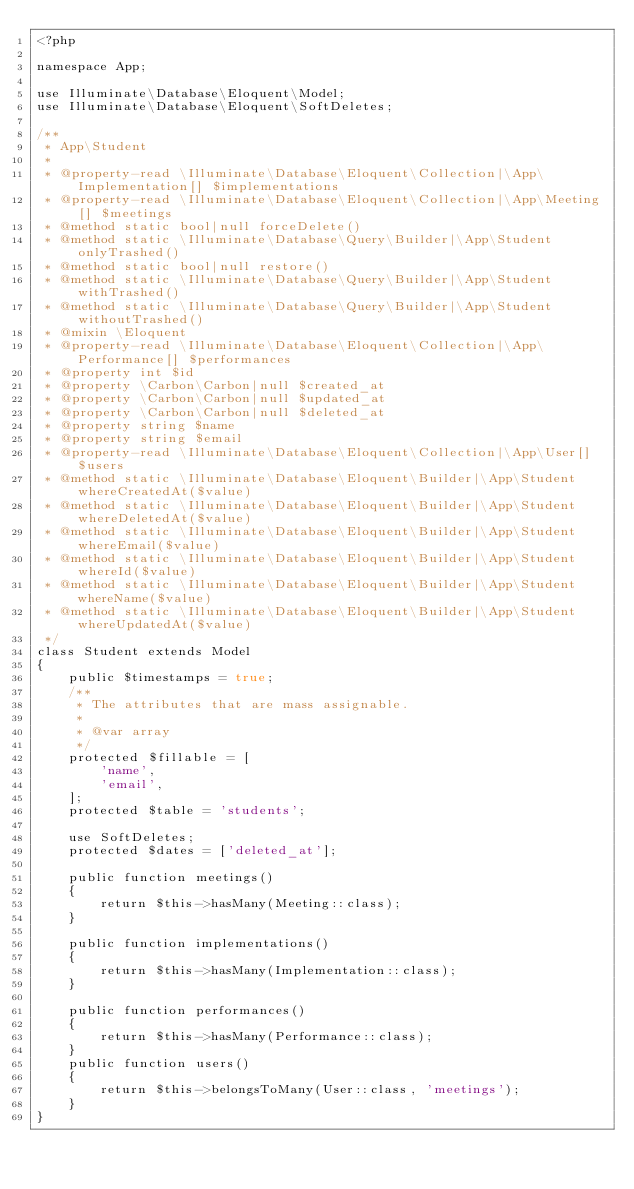Convert code to text. <code><loc_0><loc_0><loc_500><loc_500><_PHP_><?php

namespace App;

use Illuminate\Database\Eloquent\Model;
use Illuminate\Database\Eloquent\SoftDeletes;

/**
 * App\Student
 *
 * @property-read \Illuminate\Database\Eloquent\Collection|\App\Implementation[] $implementations
 * @property-read \Illuminate\Database\Eloquent\Collection|\App\Meeting[] $meetings
 * @method static bool|null forceDelete()
 * @method static \Illuminate\Database\Query\Builder|\App\Student onlyTrashed()
 * @method static bool|null restore()
 * @method static \Illuminate\Database\Query\Builder|\App\Student withTrashed()
 * @method static \Illuminate\Database\Query\Builder|\App\Student withoutTrashed()
 * @mixin \Eloquent
 * @property-read \Illuminate\Database\Eloquent\Collection|\App\Performance[] $performances
 * @property int $id
 * @property \Carbon\Carbon|null $created_at
 * @property \Carbon\Carbon|null $updated_at
 * @property \Carbon\Carbon|null $deleted_at
 * @property string $name
 * @property string $email
 * @property-read \Illuminate\Database\Eloquent\Collection|\App\User[] $users
 * @method static \Illuminate\Database\Eloquent\Builder|\App\Student whereCreatedAt($value)
 * @method static \Illuminate\Database\Eloquent\Builder|\App\Student whereDeletedAt($value)
 * @method static \Illuminate\Database\Eloquent\Builder|\App\Student whereEmail($value)
 * @method static \Illuminate\Database\Eloquent\Builder|\App\Student whereId($value)
 * @method static \Illuminate\Database\Eloquent\Builder|\App\Student whereName($value)
 * @method static \Illuminate\Database\Eloquent\Builder|\App\Student whereUpdatedAt($value)
 */
class Student extends Model
{
    public $timestamps = true;
    /**
     * The attributes that are mass assignable.
     *
     * @var array
     */
    protected $fillable = [
        'name',
        'email',
    ];
    protected $table = 'students';

    use SoftDeletes;
    protected $dates = ['deleted_at'];

    public function meetings()
    {
        return $this->hasMany(Meeting::class);
    }

    public function implementations()
    {
        return $this->hasMany(Implementation::class);
    }

    public function performances()
    {
        return $this->hasMany(Performance::class);
    }
    public function users()
    {
        return $this->belongsToMany(User::class, 'meetings');
    }
}
</code> 